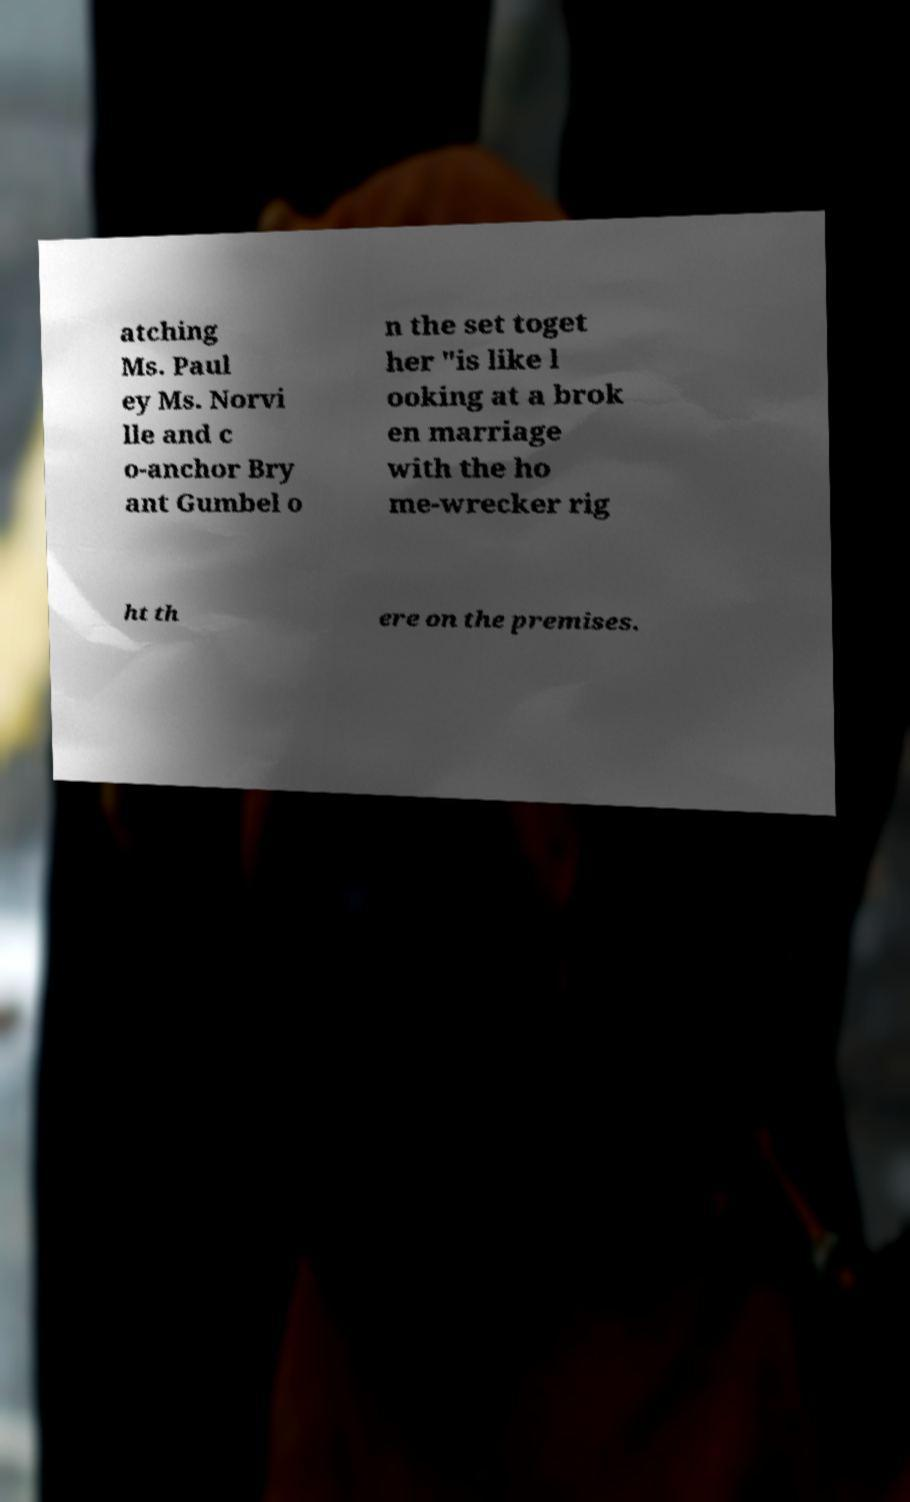There's text embedded in this image that I need extracted. Can you transcribe it verbatim? atching Ms. Paul ey Ms. Norvi lle and c o-anchor Bry ant Gumbel o n the set toget her "is like l ooking at a brok en marriage with the ho me-wrecker rig ht th ere on the premises. 